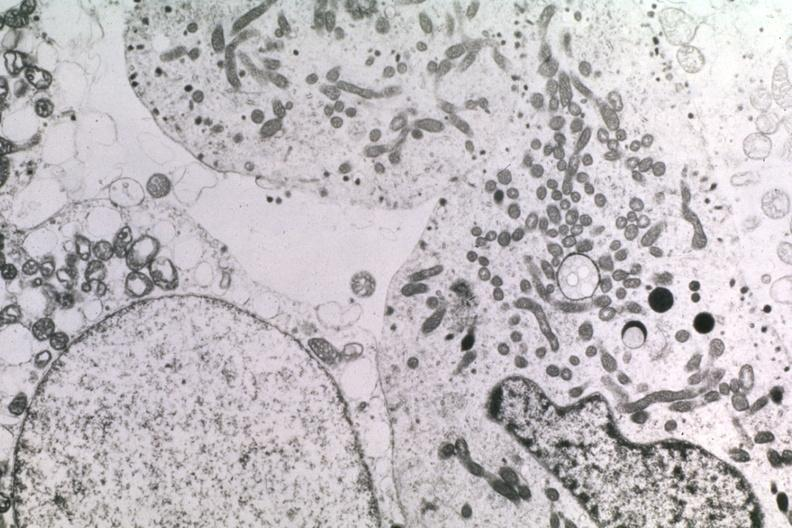what is present?
Answer the question using a single word or phrase. Adenoma 